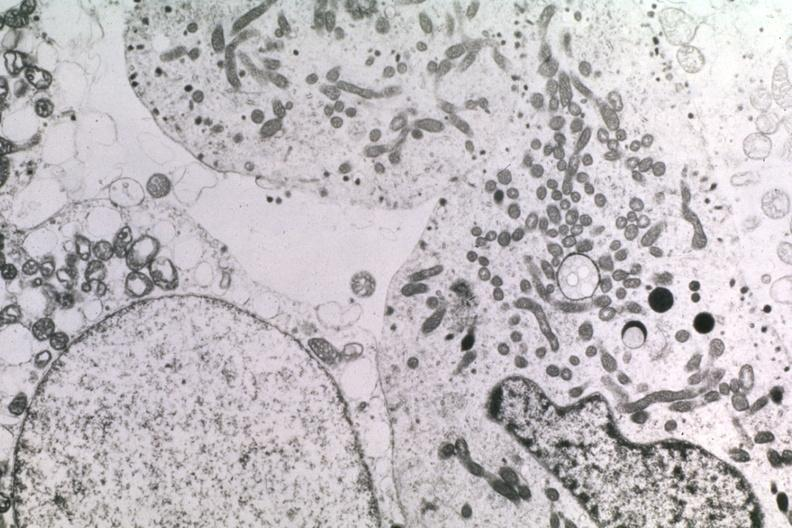what is present?
Answer the question using a single word or phrase. Adenoma 